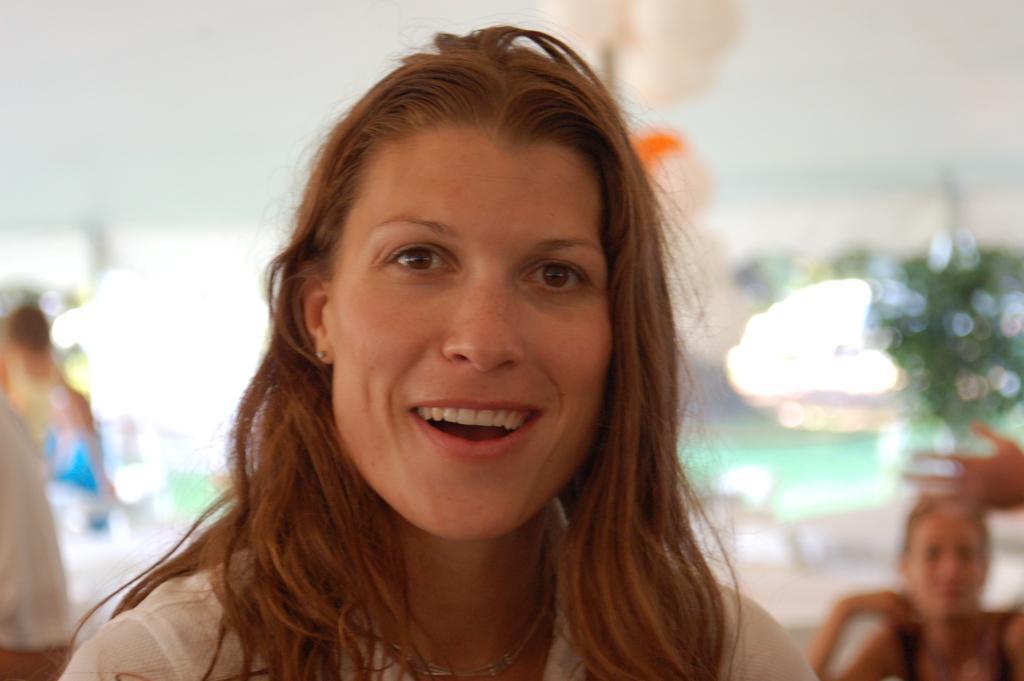In one or two sentences, can you explain what this image depicts? In this image, we can see a woman is watching and smiling. Background we can see the blur view. Here we can see few people. 